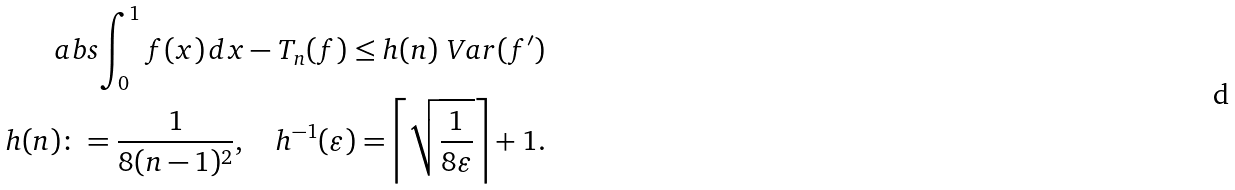<formula> <loc_0><loc_0><loc_500><loc_500>\ a b s { \int _ { 0 } ^ { 1 } f ( x ) \, d x - T _ { n } ( f ) } \leq h ( n ) \ V a r ( f ^ { \prime } ) \\ h ( n ) \colon = \frac { 1 } { 8 ( n - 1 ) ^ { 2 } } , \quad h ^ { - 1 } ( \varepsilon ) = \left \lceil \sqrt { \frac { 1 } { 8 \varepsilon } } \right \rceil + 1 .</formula> 